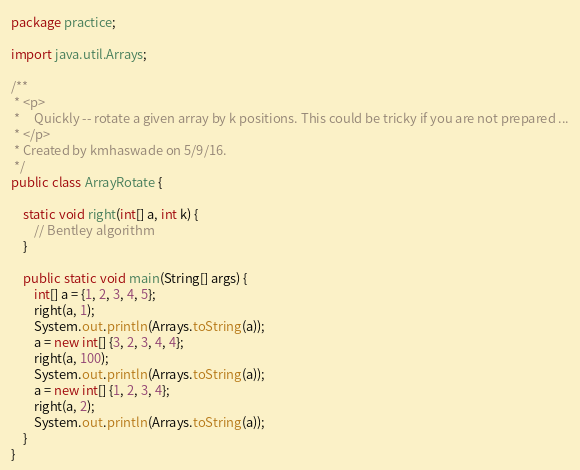<code> <loc_0><loc_0><loc_500><loc_500><_Java_>package practice;

import java.util.Arrays;

/**
 * <p>
 *     Quickly -- rotate a given array by k positions. This could be tricky if you are not prepared ...
 * </p>
 * Created by kmhaswade on 5/9/16.
 */
public class ArrayRotate {

    static void right(int[] a, int k) {
        // Bentley algorithm
    }

    public static void main(String[] args) {
        int[] a = {1, 2, 3, 4, 5};
        right(a, 1);
        System.out.println(Arrays.toString(a));
        a = new int[] {3, 2, 3, 4, 4};
        right(a, 100);
        System.out.println(Arrays.toString(a));
        a = new int[] {1, 2, 3, 4};
        right(a, 2);
        System.out.println(Arrays.toString(a));
    }
}
</code> 